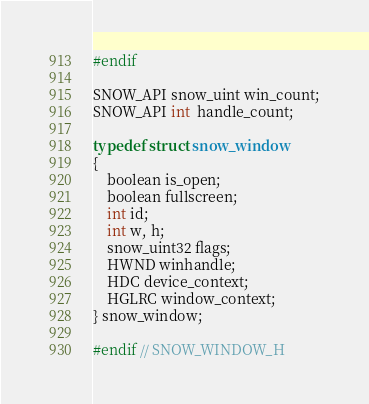<code> <loc_0><loc_0><loc_500><loc_500><_C_>#endif

SNOW_API snow_uint win_count;
SNOW_API int  handle_count;

typedef struct snow_window
{
	boolean is_open;
	boolean fullscreen;
	int id;
	int w, h;
	snow_uint32 flags;
	HWND winhandle;
	HDC device_context;
	HGLRC window_context;
} snow_window;

#endif // SNOW_WINDOW_H
</code> 